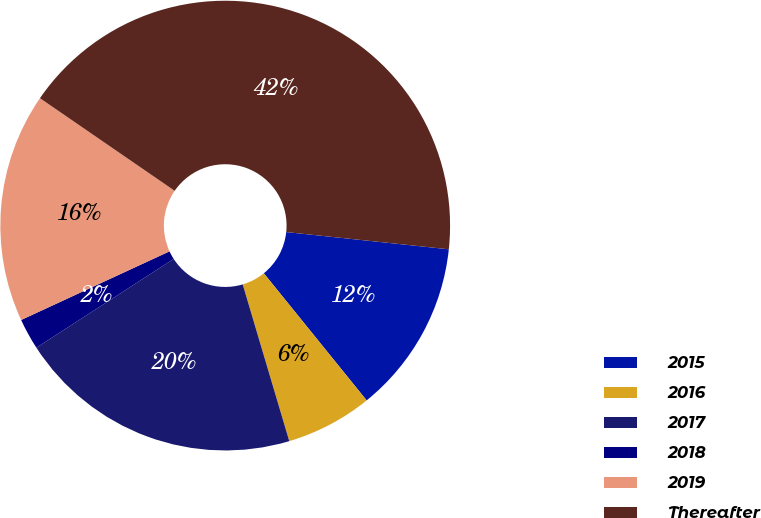Convert chart to OTSL. <chart><loc_0><loc_0><loc_500><loc_500><pie_chart><fcel>2015<fcel>2016<fcel>2017<fcel>2018<fcel>2019<fcel>Thereafter<nl><fcel>12.49%<fcel>6.23%<fcel>20.46%<fcel>2.24%<fcel>16.48%<fcel>42.09%<nl></chart> 